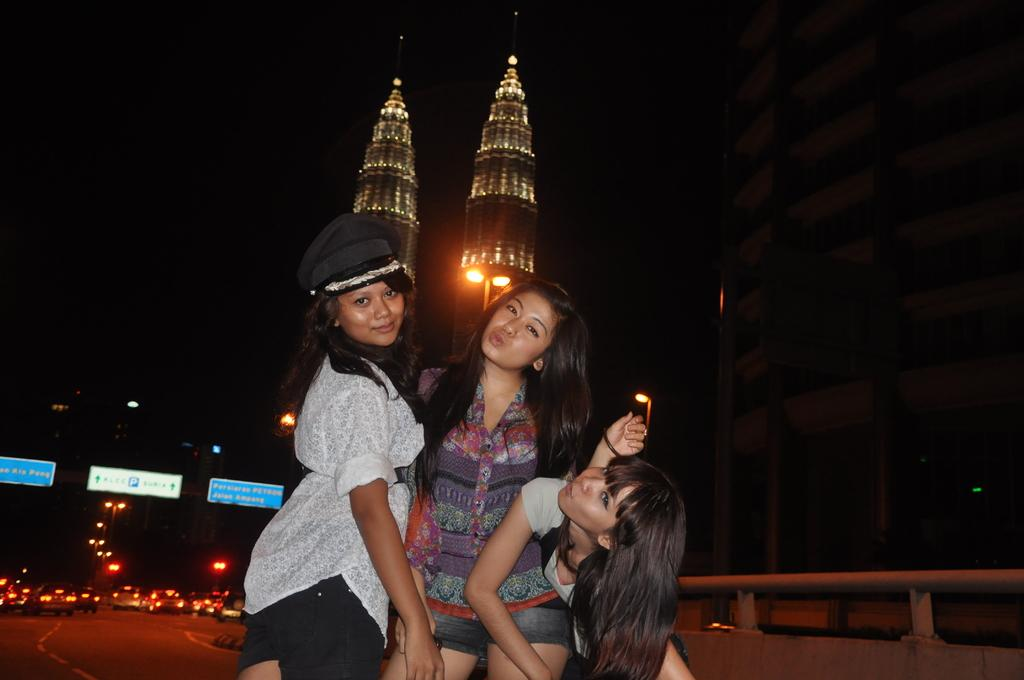How many people are in the image? There are three girls in the image. What can be seen in the background of the image? There are buildings in the background of the image. What type of transportation is visible in the image? There are cars on the road in the image. Which girl's leg is falling off in the image? There is no girl with a leg falling off in the image; all three girls appear to have both legs intact. 